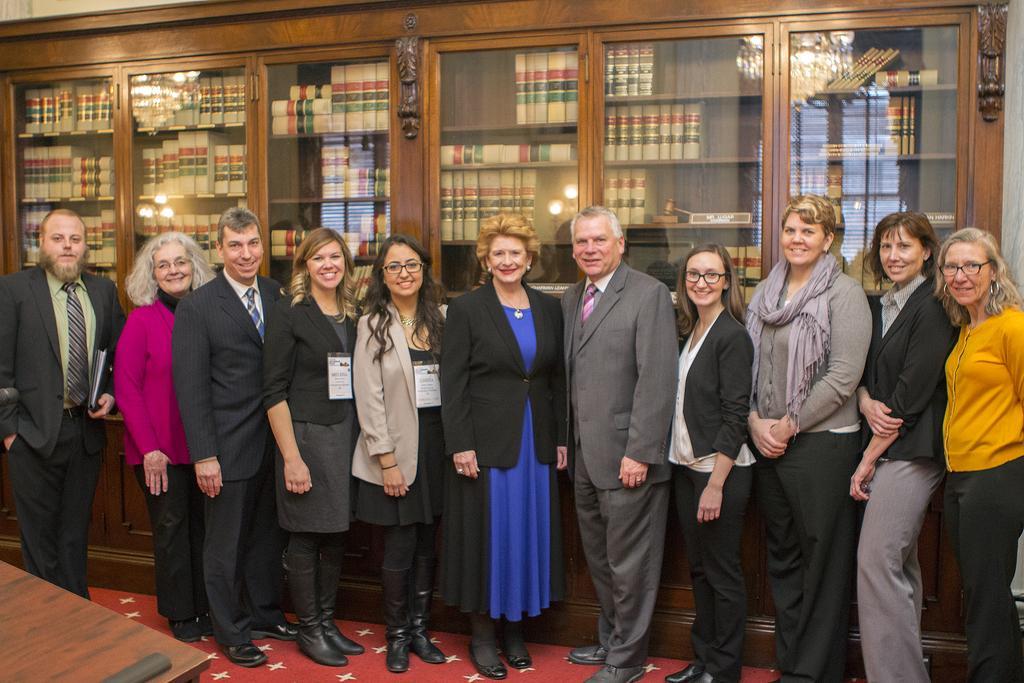Please provide a concise description of this image. In the image in the center, we can see a few people are standing. And they are smiling, which we can see on their faces. In the bottom left of the image, we can see one table. In the background there is a wall, racks, books, lights etc. 